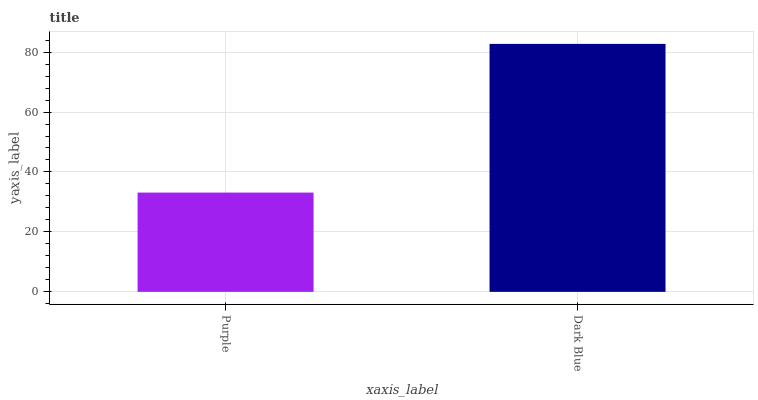Is Purple the minimum?
Answer yes or no. Yes. Is Dark Blue the maximum?
Answer yes or no. Yes. Is Dark Blue the minimum?
Answer yes or no. No. Is Dark Blue greater than Purple?
Answer yes or no. Yes. Is Purple less than Dark Blue?
Answer yes or no. Yes. Is Purple greater than Dark Blue?
Answer yes or no. No. Is Dark Blue less than Purple?
Answer yes or no. No. Is Dark Blue the high median?
Answer yes or no. Yes. Is Purple the low median?
Answer yes or no. Yes. Is Purple the high median?
Answer yes or no. No. Is Dark Blue the low median?
Answer yes or no. No. 